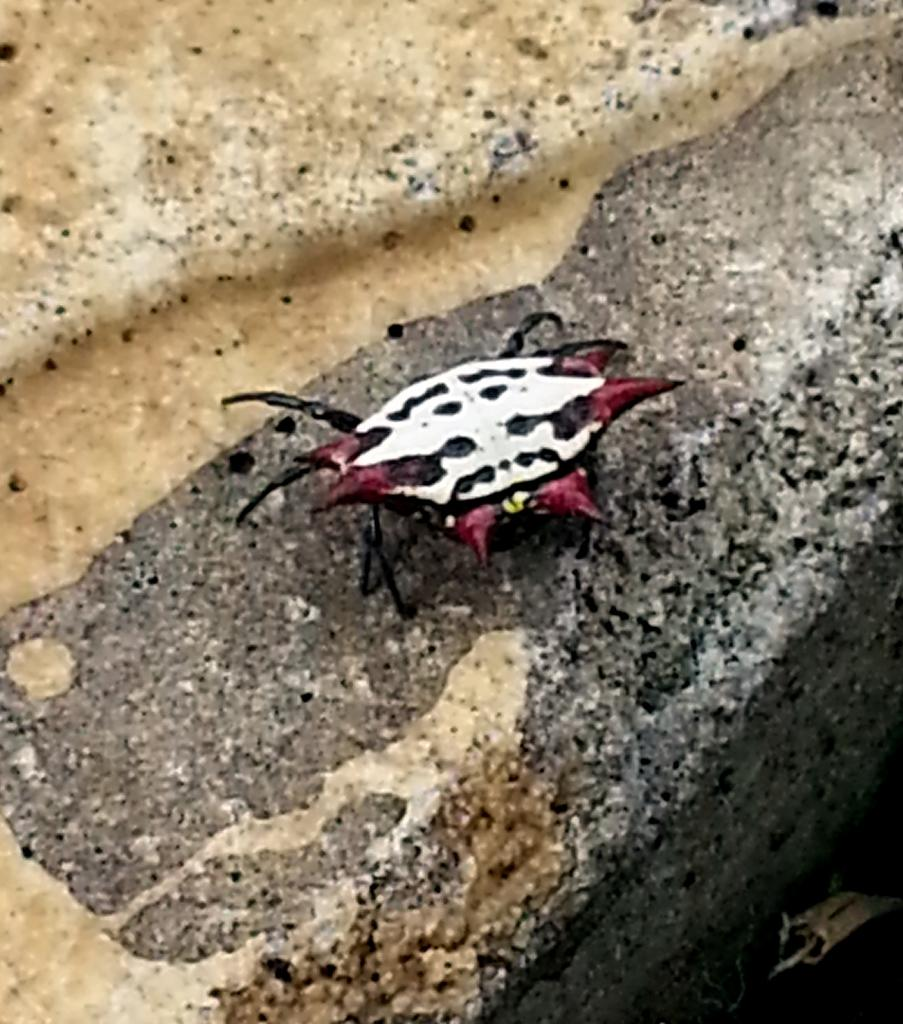What type of creature is present in the image? There is an insect in the image. Where is the insect located in the image? The insect is on the floor. How many sticks are being held by the insect's nose in the image? There are no sticks or noses present in the image, as it features an insect on the floor. 